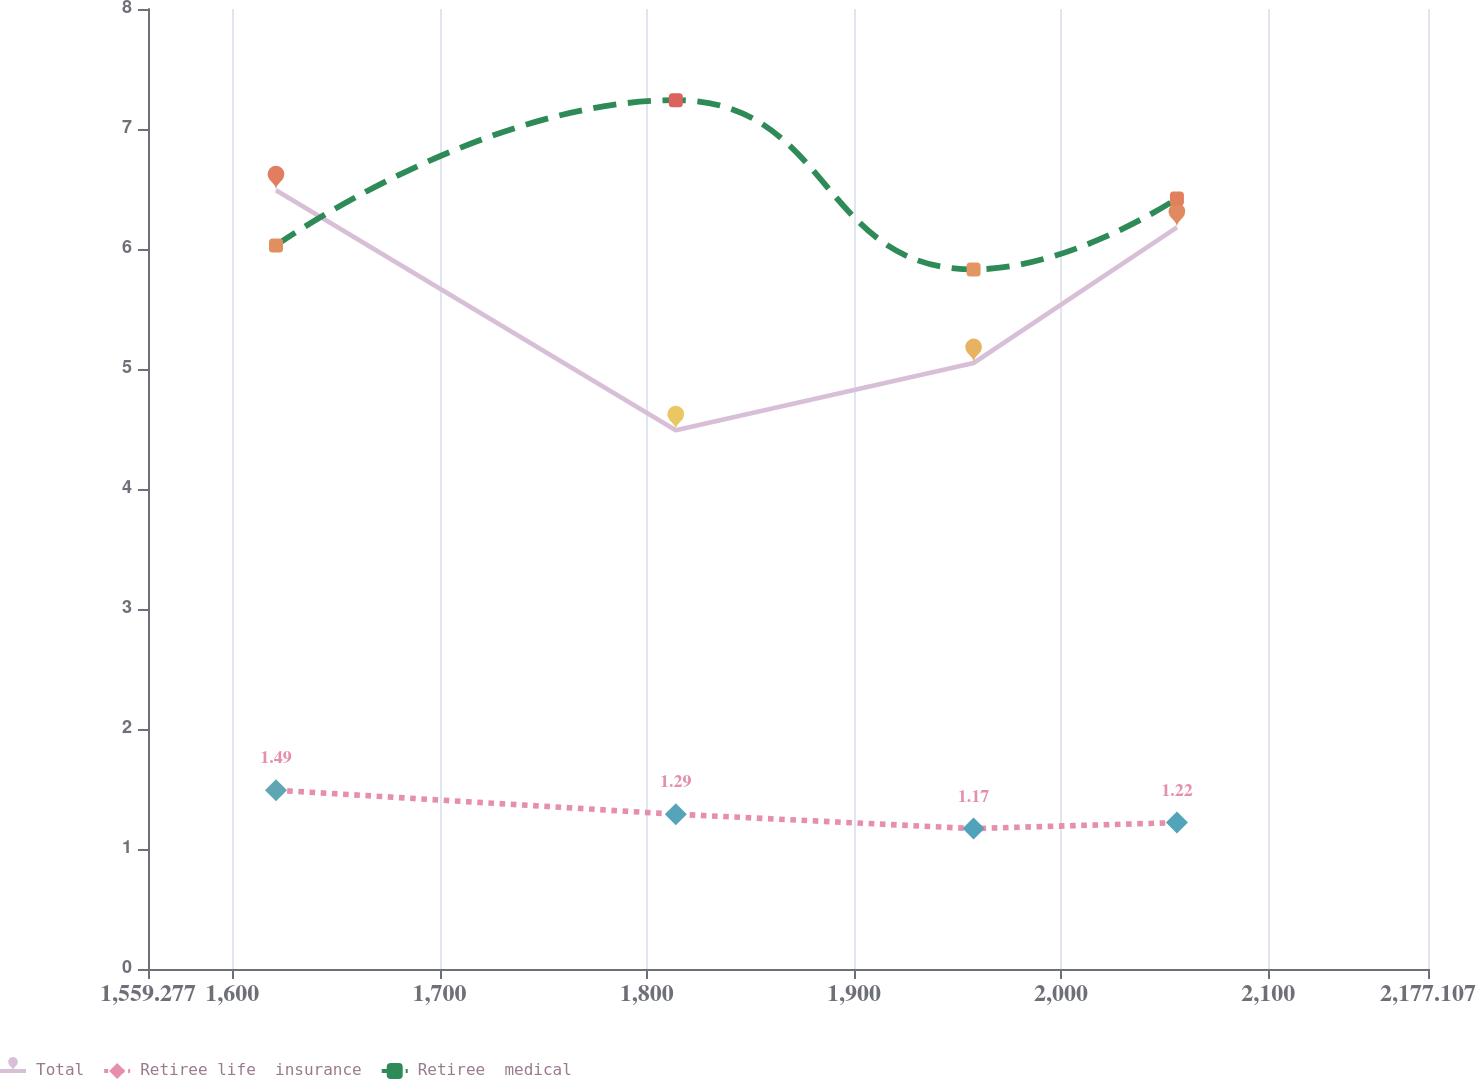Convert chart. <chart><loc_0><loc_0><loc_500><loc_500><line_chart><ecel><fcel>Total<fcel>Retiree life  insurance<fcel>Retiree  medical<nl><fcel>1621.06<fcel>6.49<fcel>1.49<fcel>6.03<nl><fcel>1814.03<fcel>4.49<fcel>1.29<fcel>7.24<nl><fcel>1957.77<fcel>5.05<fcel>1.17<fcel>5.83<nl><fcel>2055.92<fcel>6.18<fcel>1.22<fcel>6.42<nl><fcel>2238.89<fcel>5.9<fcel>1.52<fcel>7.8<nl></chart> 